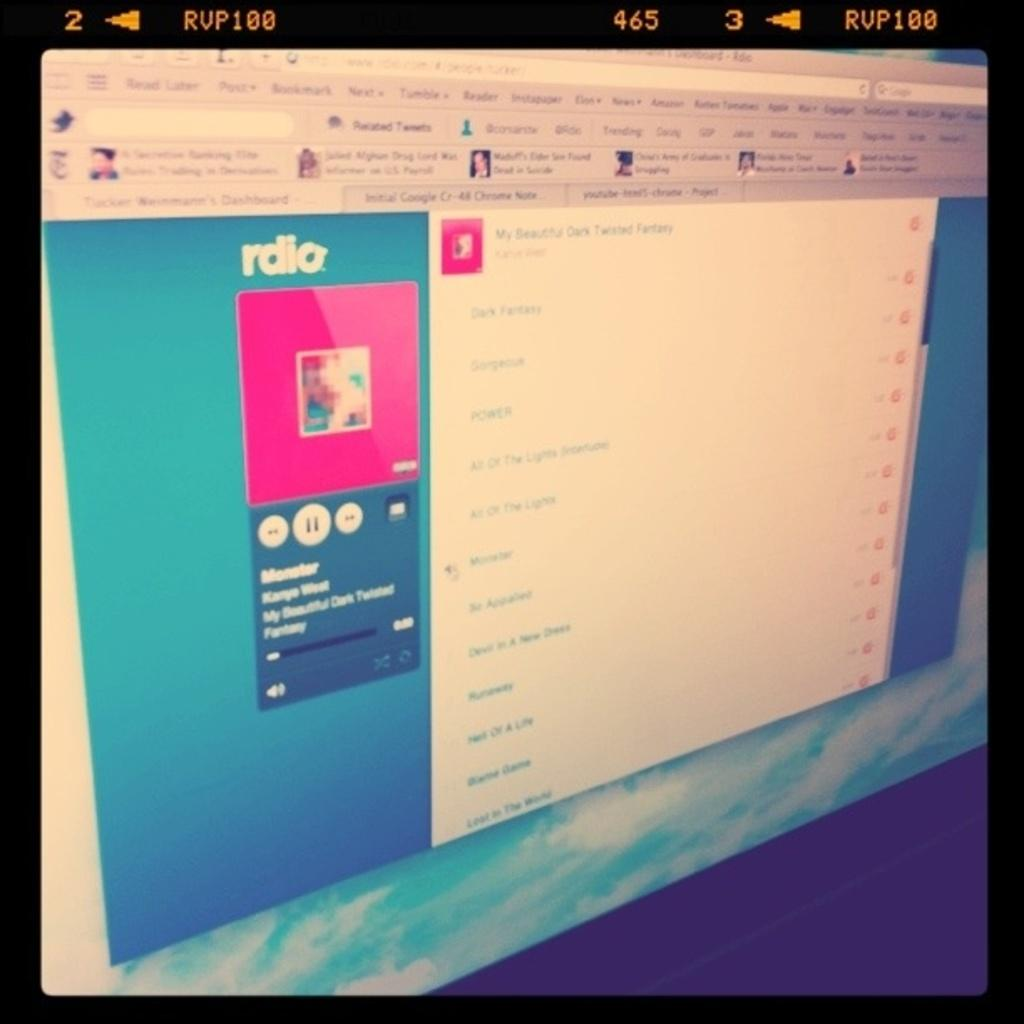<image>
Relay a brief, clear account of the picture shown. A computer display shows a page from the Rdio website. 